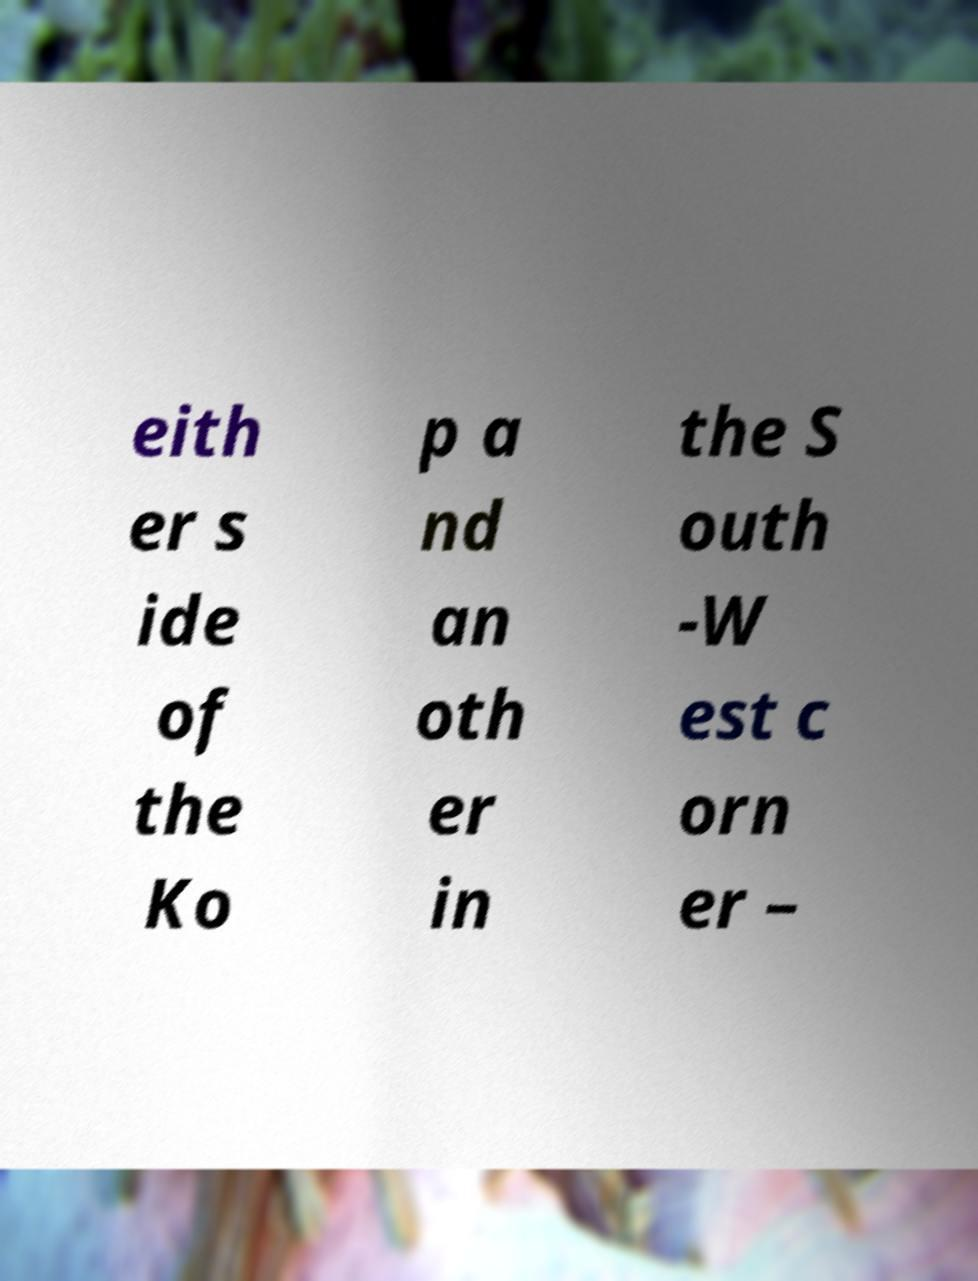For documentation purposes, I need the text within this image transcribed. Could you provide that? eith er s ide of the Ko p a nd an oth er in the S outh -W est c orn er – 